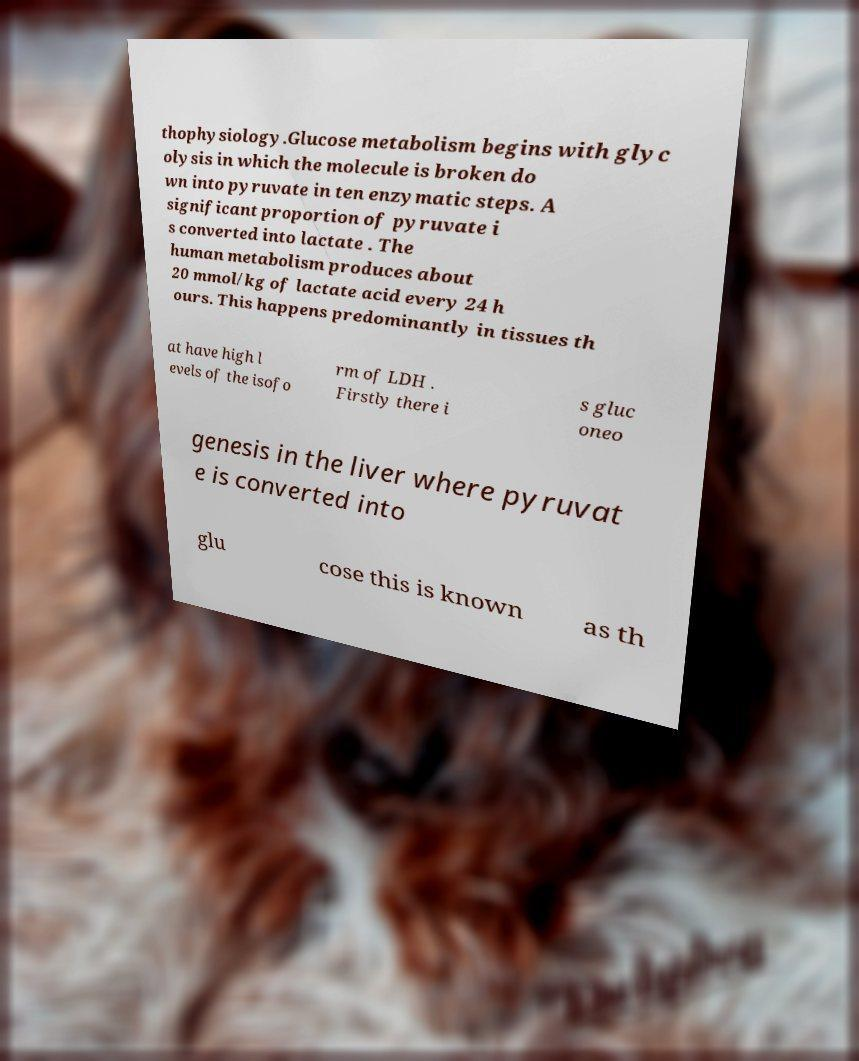What messages or text are displayed in this image? I need them in a readable, typed format. thophysiology.Glucose metabolism begins with glyc olysis in which the molecule is broken do wn into pyruvate in ten enzymatic steps. A significant proportion of pyruvate i s converted into lactate . The human metabolism produces about 20 mmol/kg of lactate acid every 24 h ours. This happens predominantly in tissues th at have high l evels of the isofo rm of LDH . Firstly there i s gluc oneo genesis in the liver where pyruvat e is converted into glu cose this is known as th 